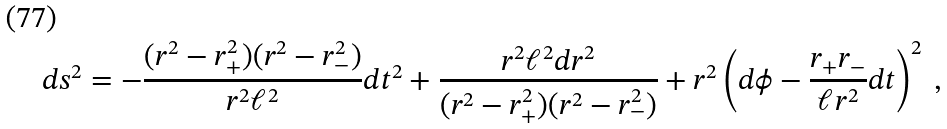Convert formula to latex. <formula><loc_0><loc_0><loc_500><loc_500>d s ^ { 2 } = - \frac { ( r ^ { 2 } - r ^ { 2 } _ { + } ) ( r ^ { 2 } - r ^ { 2 } _ { - } ) } { r ^ { 2 } \ell ^ { 2 } } d t ^ { 2 } + \frac { r ^ { 2 } \ell ^ { 2 } d r ^ { 2 } } { ( r ^ { 2 } - r ^ { 2 } _ { + } ) ( r ^ { 2 } - r ^ { 2 } _ { - } ) } + r ^ { 2 } \left ( d \phi - \frac { r _ { + } r _ { - } } { \ell r ^ { 2 } } d t \right ) ^ { 2 } \ ,</formula> 